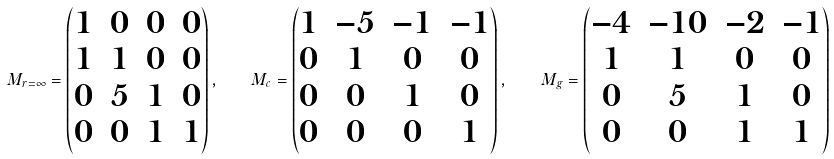Convert formula to latex. <formula><loc_0><loc_0><loc_500><loc_500>M _ { r = \infty } = \begin{pmatrix} 1 & 0 & 0 & 0 \\ 1 & 1 & 0 & 0 \\ 0 & 5 & 1 & 0 \\ 0 & 0 & 1 & 1 \end{pmatrix} , \quad M _ { c } = \begin{pmatrix} 1 & - 5 & - 1 & - 1 \\ 0 & 1 & 0 & 0 \\ 0 & 0 & 1 & 0 \\ 0 & 0 & 0 & 1 \end{pmatrix} , \quad M _ { g } = \begin{pmatrix} - 4 & - 1 0 & - 2 & - 1 \\ 1 & 1 & 0 & 0 \\ 0 & 5 & 1 & 0 \\ 0 & 0 & 1 & 1 \end{pmatrix}</formula> 